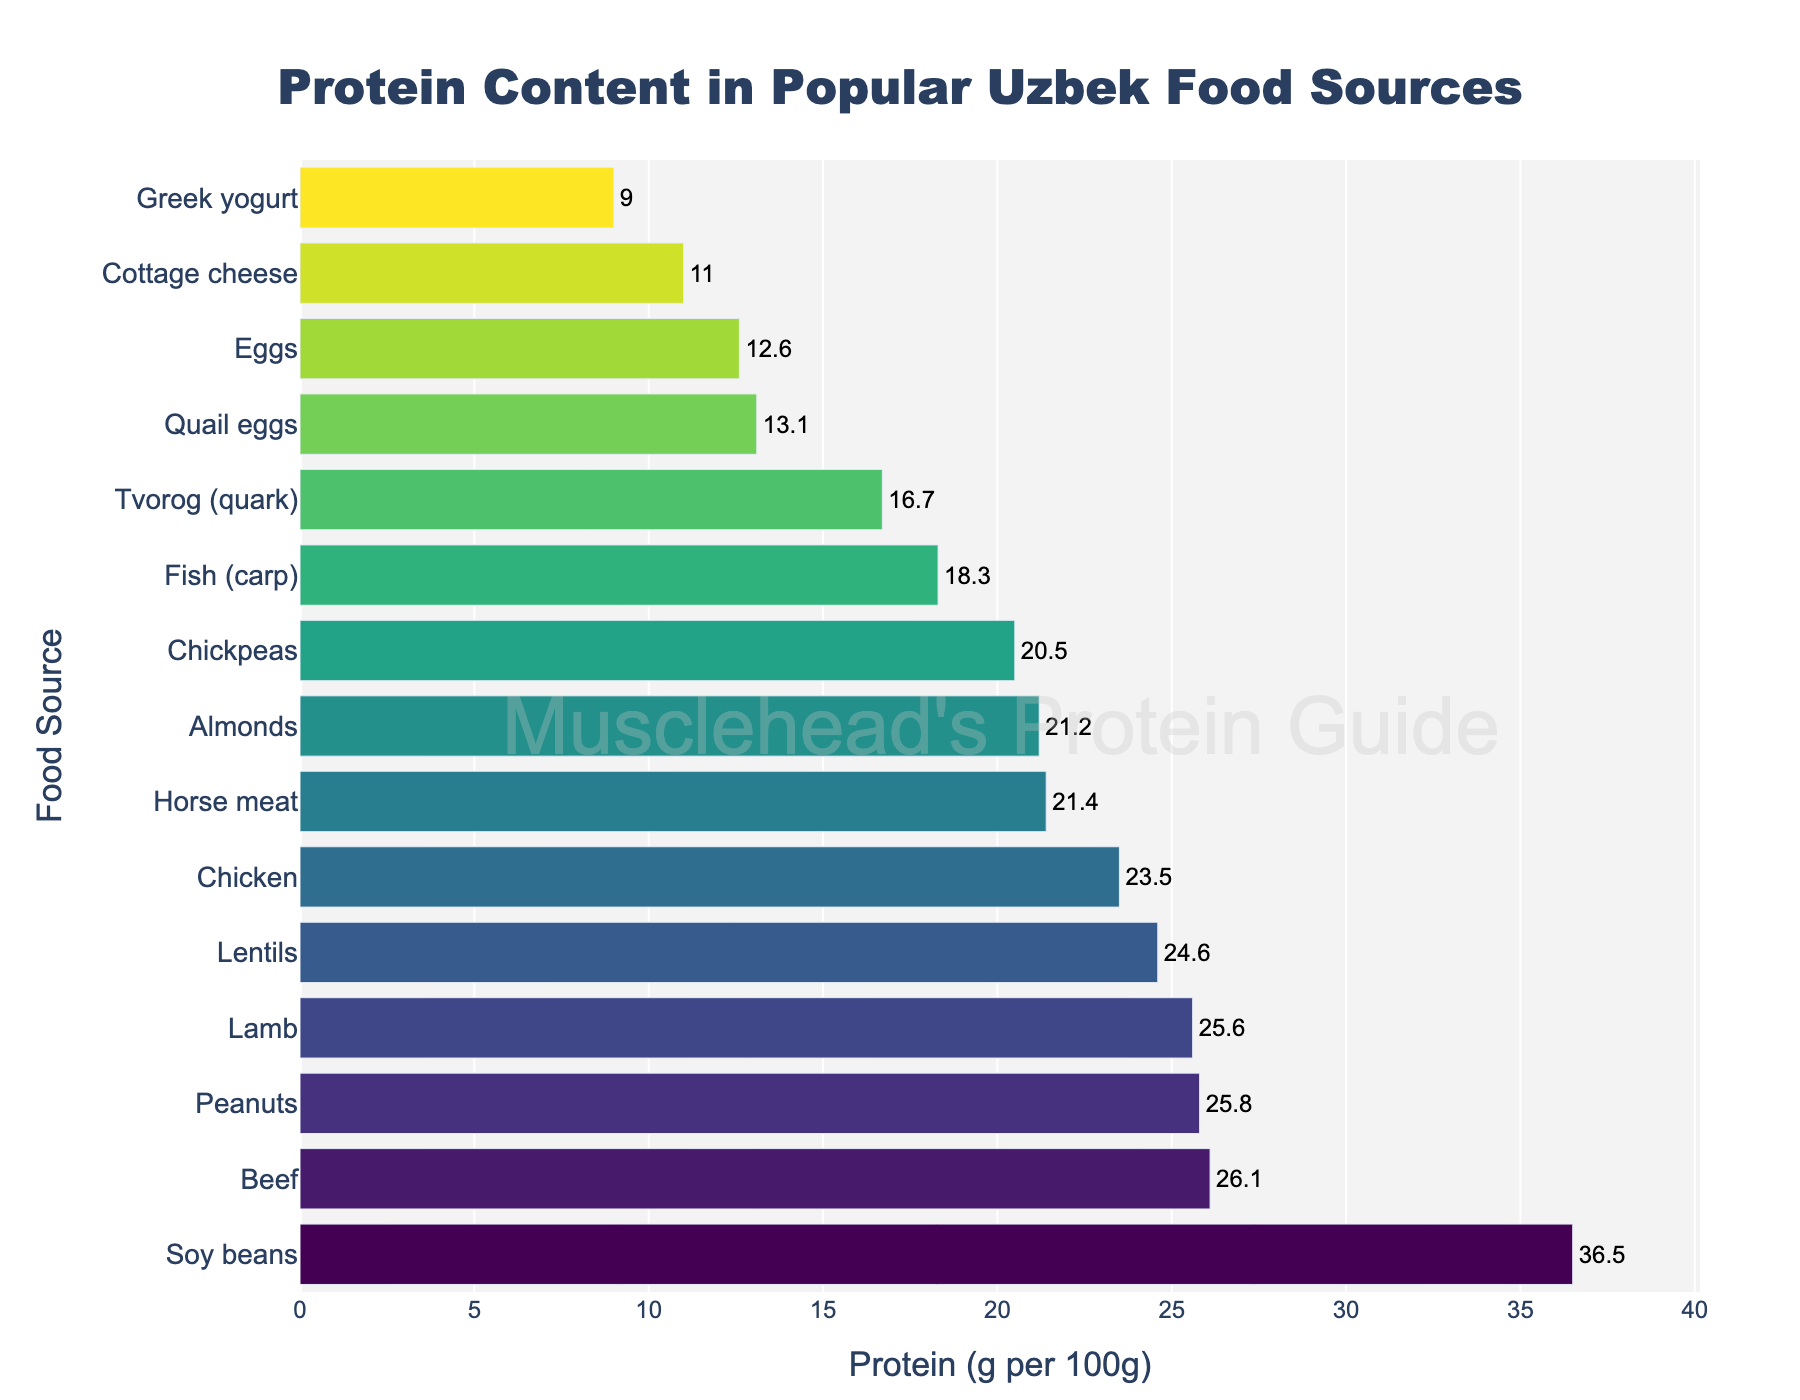Which food source has the highest protein content? The bar chart shows all food sources, with the lengths indicating their protein content. The longest bar represents Soy beans with the highest protein content.
Answer: Soy beans Which has more protein content per 100g, beef or chicken? To compare beef and chicken, refer to their respective bars. The bar for beef is longer than that for chicken, indicating higher protein content.
Answer: Beef What is the difference in protein content between peanuts and chicken? First, identify the protein content for each: Peanuts (25.8g) and Chicken (23.5g). The difference is 25.8 - 23.5.
Answer: 2.3g Sum the protein content of fish (carp), eggs, and almonds. Identify each protein value: Fish (18.3g), Eggs (12.6g), Almonds (21.2g). Add these values: 18.3 + 12.6 + 21.2.
Answer: 52.1g What is the median protein content of all the food sources? List all protein values in ascending order and find the middle value(s). Since there are 15 food sources, the median is the 8th value: 18.3, 11.0, 12.6, 13.1, 16.7, 9.0, 21.4, 21.2, 23.5, 24.6, 25.6, 25.8, 26.1, 36.5. The middle value is Greek yogurt (16.7g).
Answer: 21.2g Which food has the lowest protein content? The shortest bar in the chart corresponds to food with the lowest protein content, which is Greek yogurt.
Answer: Greek yogurt Are soy beans richer in protein than all types of meat listed? Look at the protein content of soy beans and compare it with all types of meat (Beef, Lamb, Horse meat, Chicken). Soy beans (36.5g) have a higher protein content than all meats listed.
Answer: Yes 